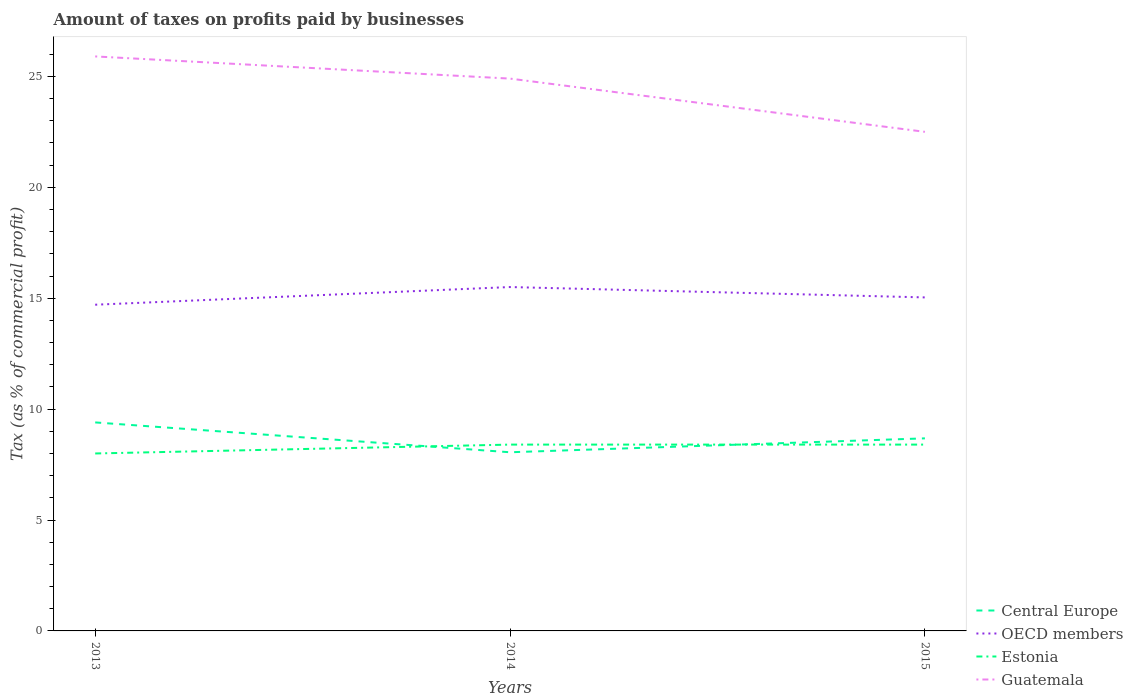How many different coloured lines are there?
Your answer should be very brief. 4. Across all years, what is the maximum percentage of taxes paid by businesses in OECD members?
Provide a short and direct response. 14.71. In which year was the percentage of taxes paid by businesses in Central Europe maximum?
Provide a succinct answer. 2014. What is the total percentage of taxes paid by businesses in Estonia in the graph?
Provide a succinct answer. -0.4. What is the difference between the highest and the second highest percentage of taxes paid by businesses in Guatemala?
Provide a short and direct response. 3.4. What is the difference between two consecutive major ticks on the Y-axis?
Offer a terse response. 5. Does the graph contain grids?
Your answer should be very brief. No. Where does the legend appear in the graph?
Provide a short and direct response. Bottom right. What is the title of the graph?
Provide a succinct answer. Amount of taxes on profits paid by businesses. Does "Egypt, Arab Rep." appear as one of the legend labels in the graph?
Ensure brevity in your answer.  No. What is the label or title of the Y-axis?
Offer a very short reply. Tax (as % of commercial profit). What is the Tax (as % of commercial profit) in OECD members in 2013?
Offer a very short reply. 14.71. What is the Tax (as % of commercial profit) in Estonia in 2013?
Make the answer very short. 8. What is the Tax (as % of commercial profit) of Guatemala in 2013?
Your response must be concise. 25.9. What is the Tax (as % of commercial profit) in Central Europe in 2014?
Ensure brevity in your answer.  8.05. What is the Tax (as % of commercial profit) of OECD members in 2014?
Keep it short and to the point. 15.5. What is the Tax (as % of commercial profit) in Estonia in 2014?
Your answer should be compact. 8.4. What is the Tax (as % of commercial profit) in Guatemala in 2014?
Give a very brief answer. 24.9. What is the Tax (as % of commercial profit) in Central Europe in 2015?
Offer a terse response. 8.68. What is the Tax (as % of commercial profit) in OECD members in 2015?
Keep it short and to the point. 15.04. What is the Tax (as % of commercial profit) of Estonia in 2015?
Your answer should be very brief. 8.4. What is the Tax (as % of commercial profit) of Guatemala in 2015?
Keep it short and to the point. 22.5. Across all years, what is the maximum Tax (as % of commercial profit) of OECD members?
Provide a short and direct response. 15.5. Across all years, what is the maximum Tax (as % of commercial profit) in Estonia?
Offer a terse response. 8.4. Across all years, what is the maximum Tax (as % of commercial profit) of Guatemala?
Provide a succinct answer. 25.9. Across all years, what is the minimum Tax (as % of commercial profit) in Central Europe?
Your answer should be very brief. 8.05. Across all years, what is the minimum Tax (as % of commercial profit) in OECD members?
Offer a terse response. 14.71. Across all years, what is the minimum Tax (as % of commercial profit) of Guatemala?
Ensure brevity in your answer.  22.5. What is the total Tax (as % of commercial profit) of Central Europe in the graph?
Give a very brief answer. 26.14. What is the total Tax (as % of commercial profit) of OECD members in the graph?
Give a very brief answer. 45.25. What is the total Tax (as % of commercial profit) of Estonia in the graph?
Keep it short and to the point. 24.8. What is the total Tax (as % of commercial profit) of Guatemala in the graph?
Ensure brevity in your answer.  73.3. What is the difference between the Tax (as % of commercial profit) of Central Europe in 2013 and that in 2014?
Your response must be concise. 1.35. What is the difference between the Tax (as % of commercial profit) of OECD members in 2013 and that in 2014?
Make the answer very short. -0.8. What is the difference between the Tax (as % of commercial profit) in Guatemala in 2013 and that in 2014?
Make the answer very short. 1. What is the difference between the Tax (as % of commercial profit) of Central Europe in 2013 and that in 2015?
Your response must be concise. 0.72. What is the difference between the Tax (as % of commercial profit) in OECD members in 2013 and that in 2015?
Give a very brief answer. -0.33. What is the difference between the Tax (as % of commercial profit) in Estonia in 2013 and that in 2015?
Keep it short and to the point. -0.4. What is the difference between the Tax (as % of commercial profit) of Central Europe in 2014 and that in 2015?
Your response must be concise. -0.63. What is the difference between the Tax (as % of commercial profit) in OECD members in 2014 and that in 2015?
Keep it short and to the point. 0.47. What is the difference between the Tax (as % of commercial profit) of Estonia in 2014 and that in 2015?
Give a very brief answer. 0. What is the difference between the Tax (as % of commercial profit) in Guatemala in 2014 and that in 2015?
Provide a succinct answer. 2.4. What is the difference between the Tax (as % of commercial profit) of Central Europe in 2013 and the Tax (as % of commercial profit) of OECD members in 2014?
Provide a succinct answer. -6.1. What is the difference between the Tax (as % of commercial profit) of Central Europe in 2013 and the Tax (as % of commercial profit) of Guatemala in 2014?
Your answer should be very brief. -15.5. What is the difference between the Tax (as % of commercial profit) in OECD members in 2013 and the Tax (as % of commercial profit) in Estonia in 2014?
Offer a terse response. 6.31. What is the difference between the Tax (as % of commercial profit) of OECD members in 2013 and the Tax (as % of commercial profit) of Guatemala in 2014?
Ensure brevity in your answer.  -10.19. What is the difference between the Tax (as % of commercial profit) of Estonia in 2013 and the Tax (as % of commercial profit) of Guatemala in 2014?
Ensure brevity in your answer.  -16.9. What is the difference between the Tax (as % of commercial profit) of Central Europe in 2013 and the Tax (as % of commercial profit) of OECD members in 2015?
Offer a very short reply. -5.64. What is the difference between the Tax (as % of commercial profit) of Central Europe in 2013 and the Tax (as % of commercial profit) of Estonia in 2015?
Your answer should be compact. 1. What is the difference between the Tax (as % of commercial profit) of OECD members in 2013 and the Tax (as % of commercial profit) of Estonia in 2015?
Keep it short and to the point. 6.31. What is the difference between the Tax (as % of commercial profit) of OECD members in 2013 and the Tax (as % of commercial profit) of Guatemala in 2015?
Make the answer very short. -7.79. What is the difference between the Tax (as % of commercial profit) in Estonia in 2013 and the Tax (as % of commercial profit) in Guatemala in 2015?
Ensure brevity in your answer.  -14.5. What is the difference between the Tax (as % of commercial profit) of Central Europe in 2014 and the Tax (as % of commercial profit) of OECD members in 2015?
Offer a terse response. -6.98. What is the difference between the Tax (as % of commercial profit) of Central Europe in 2014 and the Tax (as % of commercial profit) of Estonia in 2015?
Provide a short and direct response. -0.35. What is the difference between the Tax (as % of commercial profit) in Central Europe in 2014 and the Tax (as % of commercial profit) in Guatemala in 2015?
Offer a very short reply. -14.45. What is the difference between the Tax (as % of commercial profit) of OECD members in 2014 and the Tax (as % of commercial profit) of Estonia in 2015?
Give a very brief answer. 7.1. What is the difference between the Tax (as % of commercial profit) in OECD members in 2014 and the Tax (as % of commercial profit) in Guatemala in 2015?
Provide a short and direct response. -7. What is the difference between the Tax (as % of commercial profit) in Estonia in 2014 and the Tax (as % of commercial profit) in Guatemala in 2015?
Offer a terse response. -14.1. What is the average Tax (as % of commercial profit) of Central Europe per year?
Make the answer very short. 8.71. What is the average Tax (as % of commercial profit) in OECD members per year?
Provide a short and direct response. 15.08. What is the average Tax (as % of commercial profit) of Estonia per year?
Make the answer very short. 8.27. What is the average Tax (as % of commercial profit) of Guatemala per year?
Give a very brief answer. 24.43. In the year 2013, what is the difference between the Tax (as % of commercial profit) of Central Europe and Tax (as % of commercial profit) of OECD members?
Your answer should be very brief. -5.31. In the year 2013, what is the difference between the Tax (as % of commercial profit) in Central Europe and Tax (as % of commercial profit) in Estonia?
Offer a terse response. 1.4. In the year 2013, what is the difference between the Tax (as % of commercial profit) of Central Europe and Tax (as % of commercial profit) of Guatemala?
Ensure brevity in your answer.  -16.5. In the year 2013, what is the difference between the Tax (as % of commercial profit) in OECD members and Tax (as % of commercial profit) in Estonia?
Provide a short and direct response. 6.71. In the year 2013, what is the difference between the Tax (as % of commercial profit) of OECD members and Tax (as % of commercial profit) of Guatemala?
Make the answer very short. -11.19. In the year 2013, what is the difference between the Tax (as % of commercial profit) of Estonia and Tax (as % of commercial profit) of Guatemala?
Your answer should be very brief. -17.9. In the year 2014, what is the difference between the Tax (as % of commercial profit) of Central Europe and Tax (as % of commercial profit) of OECD members?
Provide a short and direct response. -7.45. In the year 2014, what is the difference between the Tax (as % of commercial profit) in Central Europe and Tax (as % of commercial profit) in Estonia?
Provide a short and direct response. -0.35. In the year 2014, what is the difference between the Tax (as % of commercial profit) of Central Europe and Tax (as % of commercial profit) of Guatemala?
Offer a terse response. -16.85. In the year 2014, what is the difference between the Tax (as % of commercial profit) in OECD members and Tax (as % of commercial profit) in Estonia?
Give a very brief answer. 7.1. In the year 2014, what is the difference between the Tax (as % of commercial profit) in OECD members and Tax (as % of commercial profit) in Guatemala?
Make the answer very short. -9.4. In the year 2014, what is the difference between the Tax (as % of commercial profit) in Estonia and Tax (as % of commercial profit) in Guatemala?
Make the answer very short. -16.5. In the year 2015, what is the difference between the Tax (as % of commercial profit) of Central Europe and Tax (as % of commercial profit) of OECD members?
Keep it short and to the point. -6.35. In the year 2015, what is the difference between the Tax (as % of commercial profit) of Central Europe and Tax (as % of commercial profit) of Estonia?
Offer a very short reply. 0.28. In the year 2015, what is the difference between the Tax (as % of commercial profit) of Central Europe and Tax (as % of commercial profit) of Guatemala?
Your response must be concise. -13.82. In the year 2015, what is the difference between the Tax (as % of commercial profit) in OECD members and Tax (as % of commercial profit) in Estonia?
Your answer should be compact. 6.64. In the year 2015, what is the difference between the Tax (as % of commercial profit) in OECD members and Tax (as % of commercial profit) in Guatemala?
Your answer should be compact. -7.46. In the year 2015, what is the difference between the Tax (as % of commercial profit) of Estonia and Tax (as % of commercial profit) of Guatemala?
Ensure brevity in your answer.  -14.1. What is the ratio of the Tax (as % of commercial profit) of Central Europe in 2013 to that in 2014?
Keep it short and to the point. 1.17. What is the ratio of the Tax (as % of commercial profit) in OECD members in 2013 to that in 2014?
Give a very brief answer. 0.95. What is the ratio of the Tax (as % of commercial profit) of Estonia in 2013 to that in 2014?
Offer a very short reply. 0.95. What is the ratio of the Tax (as % of commercial profit) in Guatemala in 2013 to that in 2014?
Offer a terse response. 1.04. What is the ratio of the Tax (as % of commercial profit) of Central Europe in 2013 to that in 2015?
Offer a very short reply. 1.08. What is the ratio of the Tax (as % of commercial profit) in OECD members in 2013 to that in 2015?
Offer a very short reply. 0.98. What is the ratio of the Tax (as % of commercial profit) of Guatemala in 2013 to that in 2015?
Give a very brief answer. 1.15. What is the ratio of the Tax (as % of commercial profit) of Central Europe in 2014 to that in 2015?
Provide a succinct answer. 0.93. What is the ratio of the Tax (as % of commercial profit) in OECD members in 2014 to that in 2015?
Provide a short and direct response. 1.03. What is the ratio of the Tax (as % of commercial profit) in Guatemala in 2014 to that in 2015?
Ensure brevity in your answer.  1.11. What is the difference between the highest and the second highest Tax (as % of commercial profit) of Central Europe?
Provide a succinct answer. 0.72. What is the difference between the highest and the second highest Tax (as % of commercial profit) of OECD members?
Keep it short and to the point. 0.47. What is the difference between the highest and the lowest Tax (as % of commercial profit) in Central Europe?
Provide a succinct answer. 1.35. What is the difference between the highest and the lowest Tax (as % of commercial profit) in OECD members?
Offer a very short reply. 0.8. What is the difference between the highest and the lowest Tax (as % of commercial profit) of Estonia?
Provide a short and direct response. 0.4. 